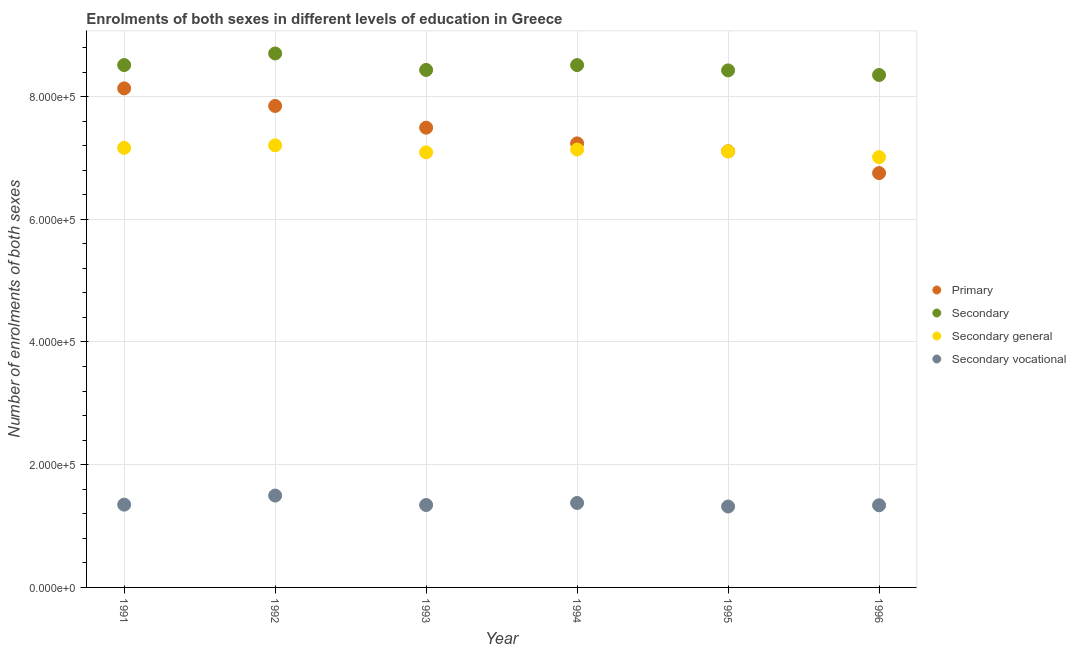Is the number of dotlines equal to the number of legend labels?
Offer a very short reply. Yes. What is the number of enrolments in secondary education in 1993?
Offer a terse response. 8.43e+05. Across all years, what is the maximum number of enrolments in secondary education?
Offer a terse response. 8.70e+05. Across all years, what is the minimum number of enrolments in secondary general education?
Your answer should be compact. 7.01e+05. In which year was the number of enrolments in secondary vocational education maximum?
Provide a succinct answer. 1992. What is the total number of enrolments in primary education in the graph?
Offer a very short reply. 4.46e+06. What is the difference between the number of enrolments in secondary education in 1991 and that in 1993?
Provide a short and direct response. 7950. What is the difference between the number of enrolments in secondary education in 1993 and the number of enrolments in secondary vocational education in 1991?
Provide a short and direct response. 7.08e+05. What is the average number of enrolments in secondary general education per year?
Offer a very short reply. 7.12e+05. In the year 1995, what is the difference between the number of enrolments in secondary vocational education and number of enrolments in primary education?
Your answer should be very brief. -5.79e+05. What is the ratio of the number of enrolments in secondary general education in 1991 to that in 1993?
Your answer should be compact. 1.01. What is the difference between the highest and the second highest number of enrolments in secondary general education?
Give a very brief answer. 4107. What is the difference between the highest and the lowest number of enrolments in secondary education?
Your response must be concise. 3.51e+04. In how many years, is the number of enrolments in secondary vocational education greater than the average number of enrolments in secondary vocational education taken over all years?
Provide a succinct answer. 2. Is the sum of the number of enrolments in secondary vocational education in 1991 and 1995 greater than the maximum number of enrolments in secondary education across all years?
Give a very brief answer. No. Does the number of enrolments in secondary vocational education monotonically increase over the years?
Provide a short and direct response. No. Is the number of enrolments in secondary vocational education strictly less than the number of enrolments in secondary education over the years?
Give a very brief answer. Yes. What is the difference between two consecutive major ticks on the Y-axis?
Give a very brief answer. 2.00e+05. Does the graph contain any zero values?
Your response must be concise. No. Where does the legend appear in the graph?
Provide a succinct answer. Center right. How are the legend labels stacked?
Your answer should be very brief. Vertical. What is the title of the graph?
Make the answer very short. Enrolments of both sexes in different levels of education in Greece. Does "Other greenhouse gases" appear as one of the legend labels in the graph?
Keep it short and to the point. No. What is the label or title of the Y-axis?
Offer a very short reply. Number of enrolments of both sexes. What is the Number of enrolments of both sexes of Primary in 1991?
Offer a very short reply. 8.13e+05. What is the Number of enrolments of both sexes of Secondary in 1991?
Your response must be concise. 8.51e+05. What is the Number of enrolments of both sexes in Secondary general in 1991?
Offer a terse response. 7.16e+05. What is the Number of enrolments of both sexes of Secondary vocational in 1991?
Provide a short and direct response. 1.35e+05. What is the Number of enrolments of both sexes in Primary in 1992?
Your answer should be very brief. 7.85e+05. What is the Number of enrolments of both sexes of Secondary in 1992?
Your response must be concise. 8.70e+05. What is the Number of enrolments of both sexes in Secondary general in 1992?
Your answer should be compact. 7.21e+05. What is the Number of enrolments of both sexes in Secondary vocational in 1992?
Provide a succinct answer. 1.50e+05. What is the Number of enrolments of both sexes in Primary in 1993?
Your answer should be compact. 7.49e+05. What is the Number of enrolments of both sexes in Secondary in 1993?
Give a very brief answer. 8.43e+05. What is the Number of enrolments of both sexes of Secondary general in 1993?
Make the answer very short. 7.09e+05. What is the Number of enrolments of both sexes in Secondary vocational in 1993?
Ensure brevity in your answer.  1.34e+05. What is the Number of enrolments of both sexes of Primary in 1994?
Keep it short and to the point. 7.24e+05. What is the Number of enrolments of both sexes in Secondary in 1994?
Offer a terse response. 8.51e+05. What is the Number of enrolments of both sexes of Secondary general in 1994?
Your answer should be compact. 7.14e+05. What is the Number of enrolments of both sexes of Secondary vocational in 1994?
Provide a succinct answer. 1.38e+05. What is the Number of enrolments of both sexes in Primary in 1995?
Your answer should be very brief. 7.11e+05. What is the Number of enrolments of both sexes of Secondary in 1995?
Provide a short and direct response. 8.43e+05. What is the Number of enrolments of both sexes in Secondary general in 1995?
Give a very brief answer. 7.11e+05. What is the Number of enrolments of both sexes in Secondary vocational in 1995?
Give a very brief answer. 1.32e+05. What is the Number of enrolments of both sexes of Primary in 1996?
Offer a terse response. 6.75e+05. What is the Number of enrolments of both sexes of Secondary in 1996?
Provide a short and direct response. 8.35e+05. What is the Number of enrolments of both sexes in Secondary general in 1996?
Your response must be concise. 7.01e+05. What is the Number of enrolments of both sexes in Secondary vocational in 1996?
Your answer should be compact. 1.34e+05. Across all years, what is the maximum Number of enrolments of both sexes of Primary?
Your response must be concise. 8.13e+05. Across all years, what is the maximum Number of enrolments of both sexes of Secondary?
Ensure brevity in your answer.  8.70e+05. Across all years, what is the maximum Number of enrolments of both sexes of Secondary general?
Offer a terse response. 7.21e+05. Across all years, what is the maximum Number of enrolments of both sexes of Secondary vocational?
Offer a terse response. 1.50e+05. Across all years, what is the minimum Number of enrolments of both sexes in Primary?
Make the answer very short. 6.75e+05. Across all years, what is the minimum Number of enrolments of both sexes in Secondary?
Your answer should be compact. 8.35e+05. Across all years, what is the minimum Number of enrolments of both sexes in Secondary general?
Provide a succinct answer. 7.01e+05. Across all years, what is the minimum Number of enrolments of both sexes of Secondary vocational?
Your response must be concise. 1.32e+05. What is the total Number of enrolments of both sexes of Primary in the graph?
Offer a very short reply. 4.46e+06. What is the total Number of enrolments of both sexes of Secondary in the graph?
Your response must be concise. 5.09e+06. What is the total Number of enrolments of both sexes of Secondary general in the graph?
Offer a terse response. 4.27e+06. What is the total Number of enrolments of both sexes of Secondary vocational in the graph?
Offer a very short reply. 8.22e+05. What is the difference between the Number of enrolments of both sexes in Primary in 1991 and that in 1992?
Your answer should be very brief. 2.86e+04. What is the difference between the Number of enrolments of both sexes in Secondary in 1991 and that in 1992?
Your response must be concise. -1.89e+04. What is the difference between the Number of enrolments of both sexes of Secondary general in 1991 and that in 1992?
Your response must be concise. -4107. What is the difference between the Number of enrolments of both sexes in Secondary vocational in 1991 and that in 1992?
Your response must be concise. -1.48e+04. What is the difference between the Number of enrolments of both sexes in Primary in 1991 and that in 1993?
Keep it short and to the point. 6.40e+04. What is the difference between the Number of enrolments of both sexes in Secondary in 1991 and that in 1993?
Ensure brevity in your answer.  7950. What is the difference between the Number of enrolments of both sexes in Secondary general in 1991 and that in 1993?
Provide a succinct answer. 7323. What is the difference between the Number of enrolments of both sexes of Secondary vocational in 1991 and that in 1993?
Your response must be concise. 627. What is the difference between the Number of enrolments of both sexes of Primary in 1991 and that in 1994?
Give a very brief answer. 8.97e+04. What is the difference between the Number of enrolments of both sexes of Secondary in 1991 and that in 1994?
Provide a short and direct response. 59. What is the difference between the Number of enrolments of both sexes in Secondary general in 1991 and that in 1994?
Your response must be concise. 2745. What is the difference between the Number of enrolments of both sexes of Secondary vocational in 1991 and that in 1994?
Your answer should be very brief. -2686. What is the difference between the Number of enrolments of both sexes of Primary in 1991 and that in 1995?
Your answer should be very brief. 1.03e+05. What is the difference between the Number of enrolments of both sexes in Secondary in 1991 and that in 1995?
Provide a succinct answer. 8720. What is the difference between the Number of enrolments of both sexes of Secondary general in 1991 and that in 1995?
Offer a terse response. 5645. What is the difference between the Number of enrolments of both sexes of Secondary vocational in 1991 and that in 1995?
Keep it short and to the point. 3075. What is the difference between the Number of enrolments of both sexes in Primary in 1991 and that in 1996?
Keep it short and to the point. 1.38e+05. What is the difference between the Number of enrolments of both sexes of Secondary in 1991 and that in 1996?
Your answer should be very brief. 1.62e+04. What is the difference between the Number of enrolments of both sexes in Secondary general in 1991 and that in 1996?
Offer a terse response. 1.51e+04. What is the difference between the Number of enrolments of both sexes in Secondary vocational in 1991 and that in 1996?
Provide a succinct answer. 1054. What is the difference between the Number of enrolments of both sexes of Primary in 1992 and that in 1993?
Provide a succinct answer. 3.54e+04. What is the difference between the Number of enrolments of both sexes of Secondary in 1992 and that in 1993?
Your answer should be compact. 2.68e+04. What is the difference between the Number of enrolments of both sexes of Secondary general in 1992 and that in 1993?
Ensure brevity in your answer.  1.14e+04. What is the difference between the Number of enrolments of both sexes of Secondary vocational in 1992 and that in 1993?
Give a very brief answer. 1.54e+04. What is the difference between the Number of enrolments of both sexes in Primary in 1992 and that in 1994?
Make the answer very short. 6.10e+04. What is the difference between the Number of enrolments of both sexes of Secondary in 1992 and that in 1994?
Ensure brevity in your answer.  1.89e+04. What is the difference between the Number of enrolments of both sexes in Secondary general in 1992 and that in 1994?
Offer a very short reply. 6852. What is the difference between the Number of enrolments of both sexes in Secondary vocational in 1992 and that in 1994?
Give a very brief answer. 1.21e+04. What is the difference between the Number of enrolments of both sexes in Primary in 1992 and that in 1995?
Offer a terse response. 7.39e+04. What is the difference between the Number of enrolments of both sexes of Secondary in 1992 and that in 1995?
Keep it short and to the point. 2.76e+04. What is the difference between the Number of enrolments of both sexes in Secondary general in 1992 and that in 1995?
Offer a terse response. 9752. What is the difference between the Number of enrolments of both sexes in Secondary vocational in 1992 and that in 1995?
Your response must be concise. 1.78e+04. What is the difference between the Number of enrolments of both sexes in Primary in 1992 and that in 1996?
Provide a short and direct response. 1.09e+05. What is the difference between the Number of enrolments of both sexes in Secondary in 1992 and that in 1996?
Ensure brevity in your answer.  3.51e+04. What is the difference between the Number of enrolments of both sexes in Secondary general in 1992 and that in 1996?
Give a very brief answer. 1.92e+04. What is the difference between the Number of enrolments of both sexes in Secondary vocational in 1992 and that in 1996?
Offer a very short reply. 1.58e+04. What is the difference between the Number of enrolments of both sexes in Primary in 1993 and that in 1994?
Ensure brevity in your answer.  2.56e+04. What is the difference between the Number of enrolments of both sexes of Secondary in 1993 and that in 1994?
Provide a short and direct response. -7891. What is the difference between the Number of enrolments of both sexes in Secondary general in 1993 and that in 1994?
Your answer should be very brief. -4578. What is the difference between the Number of enrolments of both sexes of Secondary vocational in 1993 and that in 1994?
Provide a short and direct response. -3313. What is the difference between the Number of enrolments of both sexes in Primary in 1993 and that in 1995?
Your response must be concise. 3.85e+04. What is the difference between the Number of enrolments of both sexes in Secondary in 1993 and that in 1995?
Offer a very short reply. 770. What is the difference between the Number of enrolments of both sexes of Secondary general in 1993 and that in 1995?
Your response must be concise. -1678. What is the difference between the Number of enrolments of both sexes in Secondary vocational in 1993 and that in 1995?
Your answer should be compact. 2448. What is the difference between the Number of enrolments of both sexes of Primary in 1993 and that in 1996?
Your response must be concise. 7.40e+04. What is the difference between the Number of enrolments of both sexes in Secondary in 1993 and that in 1996?
Offer a very short reply. 8245. What is the difference between the Number of enrolments of both sexes of Secondary general in 1993 and that in 1996?
Provide a succinct answer. 7818. What is the difference between the Number of enrolments of both sexes of Secondary vocational in 1993 and that in 1996?
Provide a succinct answer. 427. What is the difference between the Number of enrolments of both sexes of Primary in 1994 and that in 1995?
Keep it short and to the point. 1.29e+04. What is the difference between the Number of enrolments of both sexes of Secondary in 1994 and that in 1995?
Offer a terse response. 8661. What is the difference between the Number of enrolments of both sexes of Secondary general in 1994 and that in 1995?
Keep it short and to the point. 2900. What is the difference between the Number of enrolments of both sexes in Secondary vocational in 1994 and that in 1995?
Offer a very short reply. 5761. What is the difference between the Number of enrolments of both sexes in Primary in 1994 and that in 1996?
Provide a short and direct response. 4.84e+04. What is the difference between the Number of enrolments of both sexes of Secondary in 1994 and that in 1996?
Give a very brief answer. 1.61e+04. What is the difference between the Number of enrolments of both sexes of Secondary general in 1994 and that in 1996?
Your response must be concise. 1.24e+04. What is the difference between the Number of enrolments of both sexes in Secondary vocational in 1994 and that in 1996?
Provide a succinct answer. 3740. What is the difference between the Number of enrolments of both sexes of Primary in 1995 and that in 1996?
Your response must be concise. 3.55e+04. What is the difference between the Number of enrolments of both sexes in Secondary in 1995 and that in 1996?
Make the answer very short. 7475. What is the difference between the Number of enrolments of both sexes of Secondary general in 1995 and that in 1996?
Make the answer very short. 9496. What is the difference between the Number of enrolments of both sexes of Secondary vocational in 1995 and that in 1996?
Your response must be concise. -2021. What is the difference between the Number of enrolments of both sexes in Primary in 1991 and the Number of enrolments of both sexes in Secondary in 1992?
Offer a terse response. -5.69e+04. What is the difference between the Number of enrolments of both sexes in Primary in 1991 and the Number of enrolments of both sexes in Secondary general in 1992?
Offer a terse response. 9.28e+04. What is the difference between the Number of enrolments of both sexes of Primary in 1991 and the Number of enrolments of both sexes of Secondary vocational in 1992?
Ensure brevity in your answer.  6.64e+05. What is the difference between the Number of enrolments of both sexes in Secondary in 1991 and the Number of enrolments of both sexes in Secondary general in 1992?
Offer a terse response. 1.31e+05. What is the difference between the Number of enrolments of both sexes of Secondary in 1991 and the Number of enrolments of both sexes of Secondary vocational in 1992?
Provide a short and direct response. 7.02e+05. What is the difference between the Number of enrolments of both sexes of Secondary general in 1991 and the Number of enrolments of both sexes of Secondary vocational in 1992?
Ensure brevity in your answer.  5.67e+05. What is the difference between the Number of enrolments of both sexes of Primary in 1991 and the Number of enrolments of both sexes of Secondary in 1993?
Give a very brief answer. -3.00e+04. What is the difference between the Number of enrolments of both sexes in Primary in 1991 and the Number of enrolments of both sexes in Secondary general in 1993?
Keep it short and to the point. 1.04e+05. What is the difference between the Number of enrolments of both sexes of Primary in 1991 and the Number of enrolments of both sexes of Secondary vocational in 1993?
Give a very brief answer. 6.79e+05. What is the difference between the Number of enrolments of both sexes of Secondary in 1991 and the Number of enrolments of both sexes of Secondary general in 1993?
Your answer should be compact. 1.42e+05. What is the difference between the Number of enrolments of both sexes in Secondary in 1991 and the Number of enrolments of both sexes in Secondary vocational in 1993?
Provide a short and direct response. 7.17e+05. What is the difference between the Number of enrolments of both sexes in Secondary general in 1991 and the Number of enrolments of both sexes in Secondary vocational in 1993?
Keep it short and to the point. 5.82e+05. What is the difference between the Number of enrolments of both sexes in Primary in 1991 and the Number of enrolments of both sexes in Secondary in 1994?
Make the answer very short. -3.79e+04. What is the difference between the Number of enrolments of both sexes in Primary in 1991 and the Number of enrolments of both sexes in Secondary general in 1994?
Ensure brevity in your answer.  9.97e+04. What is the difference between the Number of enrolments of both sexes in Primary in 1991 and the Number of enrolments of both sexes in Secondary vocational in 1994?
Ensure brevity in your answer.  6.76e+05. What is the difference between the Number of enrolments of both sexes in Secondary in 1991 and the Number of enrolments of both sexes in Secondary general in 1994?
Your response must be concise. 1.38e+05. What is the difference between the Number of enrolments of both sexes of Secondary in 1991 and the Number of enrolments of both sexes of Secondary vocational in 1994?
Give a very brief answer. 7.14e+05. What is the difference between the Number of enrolments of both sexes of Secondary general in 1991 and the Number of enrolments of both sexes of Secondary vocational in 1994?
Keep it short and to the point. 5.79e+05. What is the difference between the Number of enrolments of both sexes in Primary in 1991 and the Number of enrolments of both sexes in Secondary in 1995?
Provide a succinct answer. -2.93e+04. What is the difference between the Number of enrolments of both sexes of Primary in 1991 and the Number of enrolments of both sexes of Secondary general in 1995?
Your answer should be very brief. 1.03e+05. What is the difference between the Number of enrolments of both sexes of Primary in 1991 and the Number of enrolments of both sexes of Secondary vocational in 1995?
Offer a terse response. 6.81e+05. What is the difference between the Number of enrolments of both sexes in Secondary in 1991 and the Number of enrolments of both sexes in Secondary general in 1995?
Your answer should be compact. 1.41e+05. What is the difference between the Number of enrolments of both sexes of Secondary in 1991 and the Number of enrolments of both sexes of Secondary vocational in 1995?
Keep it short and to the point. 7.19e+05. What is the difference between the Number of enrolments of both sexes of Secondary general in 1991 and the Number of enrolments of both sexes of Secondary vocational in 1995?
Your answer should be very brief. 5.85e+05. What is the difference between the Number of enrolments of both sexes in Primary in 1991 and the Number of enrolments of both sexes in Secondary in 1996?
Your answer should be compact. -2.18e+04. What is the difference between the Number of enrolments of both sexes in Primary in 1991 and the Number of enrolments of both sexes in Secondary general in 1996?
Your response must be concise. 1.12e+05. What is the difference between the Number of enrolments of both sexes in Primary in 1991 and the Number of enrolments of both sexes in Secondary vocational in 1996?
Provide a short and direct response. 6.79e+05. What is the difference between the Number of enrolments of both sexes of Secondary in 1991 and the Number of enrolments of both sexes of Secondary general in 1996?
Make the answer very short. 1.50e+05. What is the difference between the Number of enrolments of both sexes in Secondary in 1991 and the Number of enrolments of both sexes in Secondary vocational in 1996?
Ensure brevity in your answer.  7.17e+05. What is the difference between the Number of enrolments of both sexes of Secondary general in 1991 and the Number of enrolments of both sexes of Secondary vocational in 1996?
Make the answer very short. 5.83e+05. What is the difference between the Number of enrolments of both sexes of Primary in 1992 and the Number of enrolments of both sexes of Secondary in 1993?
Provide a short and direct response. -5.87e+04. What is the difference between the Number of enrolments of both sexes in Primary in 1992 and the Number of enrolments of both sexes in Secondary general in 1993?
Keep it short and to the point. 7.56e+04. What is the difference between the Number of enrolments of both sexes of Primary in 1992 and the Number of enrolments of both sexes of Secondary vocational in 1993?
Provide a succinct answer. 6.50e+05. What is the difference between the Number of enrolments of both sexes of Secondary in 1992 and the Number of enrolments of both sexes of Secondary general in 1993?
Provide a short and direct response. 1.61e+05. What is the difference between the Number of enrolments of both sexes of Secondary in 1992 and the Number of enrolments of both sexes of Secondary vocational in 1993?
Make the answer very short. 7.36e+05. What is the difference between the Number of enrolments of both sexes in Secondary general in 1992 and the Number of enrolments of both sexes in Secondary vocational in 1993?
Your response must be concise. 5.86e+05. What is the difference between the Number of enrolments of both sexes of Primary in 1992 and the Number of enrolments of both sexes of Secondary in 1994?
Keep it short and to the point. -6.66e+04. What is the difference between the Number of enrolments of both sexes of Primary in 1992 and the Number of enrolments of both sexes of Secondary general in 1994?
Offer a very short reply. 7.10e+04. What is the difference between the Number of enrolments of both sexes in Primary in 1992 and the Number of enrolments of both sexes in Secondary vocational in 1994?
Your answer should be compact. 6.47e+05. What is the difference between the Number of enrolments of both sexes in Secondary in 1992 and the Number of enrolments of both sexes in Secondary general in 1994?
Ensure brevity in your answer.  1.57e+05. What is the difference between the Number of enrolments of both sexes in Secondary in 1992 and the Number of enrolments of both sexes in Secondary vocational in 1994?
Offer a very short reply. 7.33e+05. What is the difference between the Number of enrolments of both sexes of Secondary general in 1992 and the Number of enrolments of both sexes of Secondary vocational in 1994?
Ensure brevity in your answer.  5.83e+05. What is the difference between the Number of enrolments of both sexes of Primary in 1992 and the Number of enrolments of both sexes of Secondary in 1995?
Ensure brevity in your answer.  -5.79e+04. What is the difference between the Number of enrolments of both sexes in Primary in 1992 and the Number of enrolments of both sexes in Secondary general in 1995?
Offer a very short reply. 7.39e+04. What is the difference between the Number of enrolments of both sexes of Primary in 1992 and the Number of enrolments of both sexes of Secondary vocational in 1995?
Give a very brief answer. 6.53e+05. What is the difference between the Number of enrolments of both sexes of Secondary in 1992 and the Number of enrolments of both sexes of Secondary general in 1995?
Offer a very short reply. 1.59e+05. What is the difference between the Number of enrolments of both sexes in Secondary in 1992 and the Number of enrolments of both sexes in Secondary vocational in 1995?
Offer a very short reply. 7.38e+05. What is the difference between the Number of enrolments of both sexes of Secondary general in 1992 and the Number of enrolments of both sexes of Secondary vocational in 1995?
Your response must be concise. 5.89e+05. What is the difference between the Number of enrolments of both sexes in Primary in 1992 and the Number of enrolments of both sexes in Secondary in 1996?
Keep it short and to the point. -5.05e+04. What is the difference between the Number of enrolments of both sexes in Primary in 1992 and the Number of enrolments of both sexes in Secondary general in 1996?
Offer a terse response. 8.34e+04. What is the difference between the Number of enrolments of both sexes of Primary in 1992 and the Number of enrolments of both sexes of Secondary vocational in 1996?
Keep it short and to the point. 6.51e+05. What is the difference between the Number of enrolments of both sexes of Secondary in 1992 and the Number of enrolments of both sexes of Secondary general in 1996?
Make the answer very short. 1.69e+05. What is the difference between the Number of enrolments of both sexes of Secondary in 1992 and the Number of enrolments of both sexes of Secondary vocational in 1996?
Make the answer very short. 7.36e+05. What is the difference between the Number of enrolments of both sexes of Secondary general in 1992 and the Number of enrolments of both sexes of Secondary vocational in 1996?
Offer a very short reply. 5.87e+05. What is the difference between the Number of enrolments of both sexes in Primary in 1993 and the Number of enrolments of both sexes in Secondary in 1994?
Your response must be concise. -1.02e+05. What is the difference between the Number of enrolments of both sexes of Primary in 1993 and the Number of enrolments of both sexes of Secondary general in 1994?
Your answer should be very brief. 3.57e+04. What is the difference between the Number of enrolments of both sexes of Primary in 1993 and the Number of enrolments of both sexes of Secondary vocational in 1994?
Offer a terse response. 6.12e+05. What is the difference between the Number of enrolments of both sexes of Secondary in 1993 and the Number of enrolments of both sexes of Secondary general in 1994?
Keep it short and to the point. 1.30e+05. What is the difference between the Number of enrolments of both sexes in Secondary in 1993 and the Number of enrolments of both sexes in Secondary vocational in 1994?
Your answer should be very brief. 7.06e+05. What is the difference between the Number of enrolments of both sexes in Secondary general in 1993 and the Number of enrolments of both sexes in Secondary vocational in 1994?
Make the answer very short. 5.71e+05. What is the difference between the Number of enrolments of both sexes in Primary in 1993 and the Number of enrolments of both sexes in Secondary in 1995?
Offer a very short reply. -9.33e+04. What is the difference between the Number of enrolments of both sexes of Primary in 1993 and the Number of enrolments of both sexes of Secondary general in 1995?
Make the answer very short. 3.86e+04. What is the difference between the Number of enrolments of both sexes of Primary in 1993 and the Number of enrolments of both sexes of Secondary vocational in 1995?
Your answer should be very brief. 6.17e+05. What is the difference between the Number of enrolments of both sexes of Secondary in 1993 and the Number of enrolments of both sexes of Secondary general in 1995?
Your response must be concise. 1.33e+05. What is the difference between the Number of enrolments of both sexes of Secondary in 1993 and the Number of enrolments of both sexes of Secondary vocational in 1995?
Your answer should be very brief. 7.12e+05. What is the difference between the Number of enrolments of both sexes in Secondary general in 1993 and the Number of enrolments of both sexes in Secondary vocational in 1995?
Provide a succinct answer. 5.77e+05. What is the difference between the Number of enrolments of both sexes in Primary in 1993 and the Number of enrolments of both sexes in Secondary in 1996?
Keep it short and to the point. -8.58e+04. What is the difference between the Number of enrolments of both sexes in Primary in 1993 and the Number of enrolments of both sexes in Secondary general in 1996?
Offer a very short reply. 4.80e+04. What is the difference between the Number of enrolments of both sexes in Primary in 1993 and the Number of enrolments of both sexes in Secondary vocational in 1996?
Your response must be concise. 6.15e+05. What is the difference between the Number of enrolments of both sexes of Secondary in 1993 and the Number of enrolments of both sexes of Secondary general in 1996?
Give a very brief answer. 1.42e+05. What is the difference between the Number of enrolments of both sexes of Secondary in 1993 and the Number of enrolments of both sexes of Secondary vocational in 1996?
Your answer should be compact. 7.10e+05. What is the difference between the Number of enrolments of both sexes in Secondary general in 1993 and the Number of enrolments of both sexes in Secondary vocational in 1996?
Provide a short and direct response. 5.75e+05. What is the difference between the Number of enrolments of both sexes of Primary in 1994 and the Number of enrolments of both sexes of Secondary in 1995?
Your response must be concise. -1.19e+05. What is the difference between the Number of enrolments of both sexes of Primary in 1994 and the Number of enrolments of both sexes of Secondary general in 1995?
Your answer should be very brief. 1.29e+04. What is the difference between the Number of enrolments of both sexes of Primary in 1994 and the Number of enrolments of both sexes of Secondary vocational in 1995?
Offer a terse response. 5.92e+05. What is the difference between the Number of enrolments of both sexes of Secondary in 1994 and the Number of enrolments of both sexes of Secondary general in 1995?
Your response must be concise. 1.41e+05. What is the difference between the Number of enrolments of both sexes in Secondary in 1994 and the Number of enrolments of both sexes in Secondary vocational in 1995?
Your answer should be very brief. 7.19e+05. What is the difference between the Number of enrolments of both sexes of Secondary general in 1994 and the Number of enrolments of both sexes of Secondary vocational in 1995?
Your answer should be very brief. 5.82e+05. What is the difference between the Number of enrolments of both sexes in Primary in 1994 and the Number of enrolments of both sexes in Secondary in 1996?
Offer a terse response. -1.11e+05. What is the difference between the Number of enrolments of both sexes in Primary in 1994 and the Number of enrolments of both sexes in Secondary general in 1996?
Ensure brevity in your answer.  2.24e+04. What is the difference between the Number of enrolments of both sexes in Primary in 1994 and the Number of enrolments of both sexes in Secondary vocational in 1996?
Give a very brief answer. 5.90e+05. What is the difference between the Number of enrolments of both sexes of Secondary in 1994 and the Number of enrolments of both sexes of Secondary general in 1996?
Ensure brevity in your answer.  1.50e+05. What is the difference between the Number of enrolments of both sexes of Secondary in 1994 and the Number of enrolments of both sexes of Secondary vocational in 1996?
Your answer should be very brief. 7.17e+05. What is the difference between the Number of enrolments of both sexes in Secondary general in 1994 and the Number of enrolments of both sexes in Secondary vocational in 1996?
Your response must be concise. 5.80e+05. What is the difference between the Number of enrolments of both sexes in Primary in 1995 and the Number of enrolments of both sexes in Secondary in 1996?
Offer a very short reply. -1.24e+05. What is the difference between the Number of enrolments of both sexes of Primary in 1995 and the Number of enrolments of both sexes of Secondary general in 1996?
Make the answer very short. 9511. What is the difference between the Number of enrolments of both sexes in Primary in 1995 and the Number of enrolments of both sexes in Secondary vocational in 1996?
Make the answer very short. 5.77e+05. What is the difference between the Number of enrolments of both sexes of Secondary in 1995 and the Number of enrolments of both sexes of Secondary general in 1996?
Keep it short and to the point. 1.41e+05. What is the difference between the Number of enrolments of both sexes of Secondary in 1995 and the Number of enrolments of both sexes of Secondary vocational in 1996?
Keep it short and to the point. 7.09e+05. What is the difference between the Number of enrolments of both sexes in Secondary general in 1995 and the Number of enrolments of both sexes in Secondary vocational in 1996?
Offer a terse response. 5.77e+05. What is the average Number of enrolments of both sexes in Primary per year?
Offer a terse response. 7.43e+05. What is the average Number of enrolments of both sexes in Secondary per year?
Make the answer very short. 8.49e+05. What is the average Number of enrolments of both sexes in Secondary general per year?
Ensure brevity in your answer.  7.12e+05. What is the average Number of enrolments of both sexes of Secondary vocational per year?
Provide a succinct answer. 1.37e+05. In the year 1991, what is the difference between the Number of enrolments of both sexes in Primary and Number of enrolments of both sexes in Secondary?
Make the answer very short. -3.80e+04. In the year 1991, what is the difference between the Number of enrolments of both sexes in Primary and Number of enrolments of both sexes in Secondary general?
Your answer should be compact. 9.69e+04. In the year 1991, what is the difference between the Number of enrolments of both sexes of Primary and Number of enrolments of both sexes of Secondary vocational?
Your response must be concise. 6.78e+05. In the year 1991, what is the difference between the Number of enrolments of both sexes in Secondary and Number of enrolments of both sexes in Secondary general?
Keep it short and to the point. 1.35e+05. In the year 1991, what is the difference between the Number of enrolments of both sexes of Secondary and Number of enrolments of both sexes of Secondary vocational?
Keep it short and to the point. 7.16e+05. In the year 1991, what is the difference between the Number of enrolments of both sexes in Secondary general and Number of enrolments of both sexes in Secondary vocational?
Offer a very short reply. 5.81e+05. In the year 1992, what is the difference between the Number of enrolments of both sexes in Primary and Number of enrolments of both sexes in Secondary?
Your answer should be very brief. -8.55e+04. In the year 1992, what is the difference between the Number of enrolments of both sexes in Primary and Number of enrolments of both sexes in Secondary general?
Give a very brief answer. 6.42e+04. In the year 1992, what is the difference between the Number of enrolments of both sexes in Primary and Number of enrolments of both sexes in Secondary vocational?
Provide a short and direct response. 6.35e+05. In the year 1992, what is the difference between the Number of enrolments of both sexes in Secondary and Number of enrolments of both sexes in Secondary general?
Keep it short and to the point. 1.50e+05. In the year 1992, what is the difference between the Number of enrolments of both sexes in Secondary and Number of enrolments of both sexes in Secondary vocational?
Ensure brevity in your answer.  7.21e+05. In the year 1992, what is the difference between the Number of enrolments of both sexes of Secondary general and Number of enrolments of both sexes of Secondary vocational?
Provide a short and direct response. 5.71e+05. In the year 1993, what is the difference between the Number of enrolments of both sexes of Primary and Number of enrolments of both sexes of Secondary?
Offer a terse response. -9.41e+04. In the year 1993, what is the difference between the Number of enrolments of both sexes of Primary and Number of enrolments of both sexes of Secondary general?
Provide a short and direct response. 4.02e+04. In the year 1993, what is the difference between the Number of enrolments of both sexes of Primary and Number of enrolments of both sexes of Secondary vocational?
Your answer should be compact. 6.15e+05. In the year 1993, what is the difference between the Number of enrolments of both sexes in Secondary and Number of enrolments of both sexes in Secondary general?
Ensure brevity in your answer.  1.34e+05. In the year 1993, what is the difference between the Number of enrolments of both sexes in Secondary and Number of enrolments of both sexes in Secondary vocational?
Your answer should be very brief. 7.09e+05. In the year 1993, what is the difference between the Number of enrolments of both sexes in Secondary general and Number of enrolments of both sexes in Secondary vocational?
Provide a short and direct response. 5.75e+05. In the year 1994, what is the difference between the Number of enrolments of both sexes in Primary and Number of enrolments of both sexes in Secondary?
Give a very brief answer. -1.28e+05. In the year 1994, what is the difference between the Number of enrolments of both sexes in Primary and Number of enrolments of both sexes in Secondary general?
Ensure brevity in your answer.  1.00e+04. In the year 1994, what is the difference between the Number of enrolments of both sexes in Primary and Number of enrolments of both sexes in Secondary vocational?
Offer a terse response. 5.86e+05. In the year 1994, what is the difference between the Number of enrolments of both sexes in Secondary and Number of enrolments of both sexes in Secondary general?
Your answer should be very brief. 1.38e+05. In the year 1994, what is the difference between the Number of enrolments of both sexes in Secondary and Number of enrolments of both sexes in Secondary vocational?
Offer a very short reply. 7.14e+05. In the year 1994, what is the difference between the Number of enrolments of both sexes of Secondary general and Number of enrolments of both sexes of Secondary vocational?
Provide a short and direct response. 5.76e+05. In the year 1995, what is the difference between the Number of enrolments of both sexes of Primary and Number of enrolments of both sexes of Secondary?
Your response must be concise. -1.32e+05. In the year 1995, what is the difference between the Number of enrolments of both sexes of Primary and Number of enrolments of both sexes of Secondary vocational?
Provide a short and direct response. 5.79e+05. In the year 1995, what is the difference between the Number of enrolments of both sexes of Secondary and Number of enrolments of both sexes of Secondary general?
Provide a succinct answer. 1.32e+05. In the year 1995, what is the difference between the Number of enrolments of both sexes of Secondary and Number of enrolments of both sexes of Secondary vocational?
Ensure brevity in your answer.  7.11e+05. In the year 1995, what is the difference between the Number of enrolments of both sexes of Secondary general and Number of enrolments of both sexes of Secondary vocational?
Ensure brevity in your answer.  5.79e+05. In the year 1996, what is the difference between the Number of enrolments of both sexes in Primary and Number of enrolments of both sexes in Secondary?
Offer a terse response. -1.60e+05. In the year 1996, what is the difference between the Number of enrolments of both sexes of Primary and Number of enrolments of both sexes of Secondary general?
Your response must be concise. -2.60e+04. In the year 1996, what is the difference between the Number of enrolments of both sexes in Primary and Number of enrolments of both sexes in Secondary vocational?
Make the answer very short. 5.41e+05. In the year 1996, what is the difference between the Number of enrolments of both sexes in Secondary and Number of enrolments of both sexes in Secondary general?
Your answer should be compact. 1.34e+05. In the year 1996, what is the difference between the Number of enrolments of both sexes of Secondary and Number of enrolments of both sexes of Secondary vocational?
Make the answer very short. 7.01e+05. In the year 1996, what is the difference between the Number of enrolments of both sexes in Secondary general and Number of enrolments of both sexes in Secondary vocational?
Provide a succinct answer. 5.67e+05. What is the ratio of the Number of enrolments of both sexes of Primary in 1991 to that in 1992?
Make the answer very short. 1.04. What is the ratio of the Number of enrolments of both sexes in Secondary in 1991 to that in 1992?
Keep it short and to the point. 0.98. What is the ratio of the Number of enrolments of both sexes of Secondary vocational in 1991 to that in 1992?
Offer a very short reply. 0.9. What is the ratio of the Number of enrolments of both sexes in Primary in 1991 to that in 1993?
Your answer should be compact. 1.09. What is the ratio of the Number of enrolments of both sexes of Secondary in 1991 to that in 1993?
Keep it short and to the point. 1.01. What is the ratio of the Number of enrolments of both sexes in Secondary general in 1991 to that in 1993?
Your answer should be compact. 1.01. What is the ratio of the Number of enrolments of both sexes in Primary in 1991 to that in 1994?
Your answer should be compact. 1.12. What is the ratio of the Number of enrolments of both sexes in Secondary general in 1991 to that in 1994?
Offer a terse response. 1. What is the ratio of the Number of enrolments of both sexes of Secondary vocational in 1991 to that in 1994?
Provide a succinct answer. 0.98. What is the ratio of the Number of enrolments of both sexes in Primary in 1991 to that in 1995?
Offer a terse response. 1.14. What is the ratio of the Number of enrolments of both sexes in Secondary in 1991 to that in 1995?
Your answer should be compact. 1.01. What is the ratio of the Number of enrolments of both sexes in Secondary general in 1991 to that in 1995?
Your response must be concise. 1.01. What is the ratio of the Number of enrolments of both sexes in Secondary vocational in 1991 to that in 1995?
Give a very brief answer. 1.02. What is the ratio of the Number of enrolments of both sexes of Primary in 1991 to that in 1996?
Your answer should be very brief. 1.2. What is the ratio of the Number of enrolments of both sexes of Secondary in 1991 to that in 1996?
Your response must be concise. 1.02. What is the ratio of the Number of enrolments of both sexes in Secondary general in 1991 to that in 1996?
Give a very brief answer. 1.02. What is the ratio of the Number of enrolments of both sexes of Secondary vocational in 1991 to that in 1996?
Keep it short and to the point. 1.01. What is the ratio of the Number of enrolments of both sexes of Primary in 1992 to that in 1993?
Provide a succinct answer. 1.05. What is the ratio of the Number of enrolments of both sexes in Secondary in 1992 to that in 1993?
Give a very brief answer. 1.03. What is the ratio of the Number of enrolments of both sexes in Secondary general in 1992 to that in 1993?
Your answer should be very brief. 1.02. What is the ratio of the Number of enrolments of both sexes in Secondary vocational in 1992 to that in 1993?
Keep it short and to the point. 1.11. What is the ratio of the Number of enrolments of both sexes in Primary in 1992 to that in 1994?
Ensure brevity in your answer.  1.08. What is the ratio of the Number of enrolments of both sexes of Secondary in 1992 to that in 1994?
Offer a very short reply. 1.02. What is the ratio of the Number of enrolments of both sexes in Secondary general in 1992 to that in 1994?
Give a very brief answer. 1.01. What is the ratio of the Number of enrolments of both sexes of Secondary vocational in 1992 to that in 1994?
Offer a terse response. 1.09. What is the ratio of the Number of enrolments of both sexes of Primary in 1992 to that in 1995?
Ensure brevity in your answer.  1.1. What is the ratio of the Number of enrolments of both sexes of Secondary in 1992 to that in 1995?
Your response must be concise. 1.03. What is the ratio of the Number of enrolments of both sexes in Secondary general in 1992 to that in 1995?
Offer a terse response. 1.01. What is the ratio of the Number of enrolments of both sexes of Secondary vocational in 1992 to that in 1995?
Give a very brief answer. 1.14. What is the ratio of the Number of enrolments of both sexes of Primary in 1992 to that in 1996?
Your answer should be very brief. 1.16. What is the ratio of the Number of enrolments of both sexes in Secondary in 1992 to that in 1996?
Offer a very short reply. 1.04. What is the ratio of the Number of enrolments of both sexes in Secondary general in 1992 to that in 1996?
Ensure brevity in your answer.  1.03. What is the ratio of the Number of enrolments of both sexes in Secondary vocational in 1992 to that in 1996?
Keep it short and to the point. 1.12. What is the ratio of the Number of enrolments of both sexes in Primary in 1993 to that in 1994?
Give a very brief answer. 1.04. What is the ratio of the Number of enrolments of both sexes in Secondary vocational in 1993 to that in 1994?
Ensure brevity in your answer.  0.98. What is the ratio of the Number of enrolments of both sexes of Primary in 1993 to that in 1995?
Offer a very short reply. 1.05. What is the ratio of the Number of enrolments of both sexes of Secondary in 1993 to that in 1995?
Make the answer very short. 1. What is the ratio of the Number of enrolments of both sexes of Secondary vocational in 1993 to that in 1995?
Make the answer very short. 1.02. What is the ratio of the Number of enrolments of both sexes in Primary in 1993 to that in 1996?
Offer a terse response. 1.11. What is the ratio of the Number of enrolments of both sexes in Secondary in 1993 to that in 1996?
Provide a short and direct response. 1.01. What is the ratio of the Number of enrolments of both sexes in Secondary general in 1993 to that in 1996?
Offer a terse response. 1.01. What is the ratio of the Number of enrolments of both sexes in Primary in 1994 to that in 1995?
Provide a succinct answer. 1.02. What is the ratio of the Number of enrolments of both sexes in Secondary in 1994 to that in 1995?
Make the answer very short. 1.01. What is the ratio of the Number of enrolments of both sexes of Secondary general in 1994 to that in 1995?
Your answer should be very brief. 1. What is the ratio of the Number of enrolments of both sexes in Secondary vocational in 1994 to that in 1995?
Your answer should be very brief. 1.04. What is the ratio of the Number of enrolments of both sexes in Primary in 1994 to that in 1996?
Your answer should be compact. 1.07. What is the ratio of the Number of enrolments of both sexes of Secondary in 1994 to that in 1996?
Keep it short and to the point. 1.02. What is the ratio of the Number of enrolments of both sexes of Secondary general in 1994 to that in 1996?
Your response must be concise. 1.02. What is the ratio of the Number of enrolments of both sexes in Secondary vocational in 1994 to that in 1996?
Your answer should be compact. 1.03. What is the ratio of the Number of enrolments of both sexes in Primary in 1995 to that in 1996?
Ensure brevity in your answer.  1.05. What is the ratio of the Number of enrolments of both sexes of Secondary in 1995 to that in 1996?
Keep it short and to the point. 1.01. What is the ratio of the Number of enrolments of both sexes of Secondary general in 1995 to that in 1996?
Keep it short and to the point. 1.01. What is the ratio of the Number of enrolments of both sexes in Secondary vocational in 1995 to that in 1996?
Make the answer very short. 0.98. What is the difference between the highest and the second highest Number of enrolments of both sexes of Primary?
Make the answer very short. 2.86e+04. What is the difference between the highest and the second highest Number of enrolments of both sexes in Secondary?
Make the answer very short. 1.89e+04. What is the difference between the highest and the second highest Number of enrolments of both sexes of Secondary general?
Your answer should be very brief. 4107. What is the difference between the highest and the second highest Number of enrolments of both sexes in Secondary vocational?
Your answer should be compact. 1.21e+04. What is the difference between the highest and the lowest Number of enrolments of both sexes of Primary?
Your response must be concise. 1.38e+05. What is the difference between the highest and the lowest Number of enrolments of both sexes of Secondary?
Offer a very short reply. 3.51e+04. What is the difference between the highest and the lowest Number of enrolments of both sexes of Secondary general?
Your response must be concise. 1.92e+04. What is the difference between the highest and the lowest Number of enrolments of both sexes in Secondary vocational?
Provide a short and direct response. 1.78e+04. 